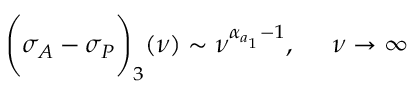<formula> <loc_0><loc_0><loc_500><loc_500>\left ( \sigma _ { A } - \sigma _ { P } \right ) _ { 3 } ( \nu ) \sim \nu ^ { \alpha _ { a _ { 1 } } - 1 } , \quad \nu \rightarrow \infty</formula> 